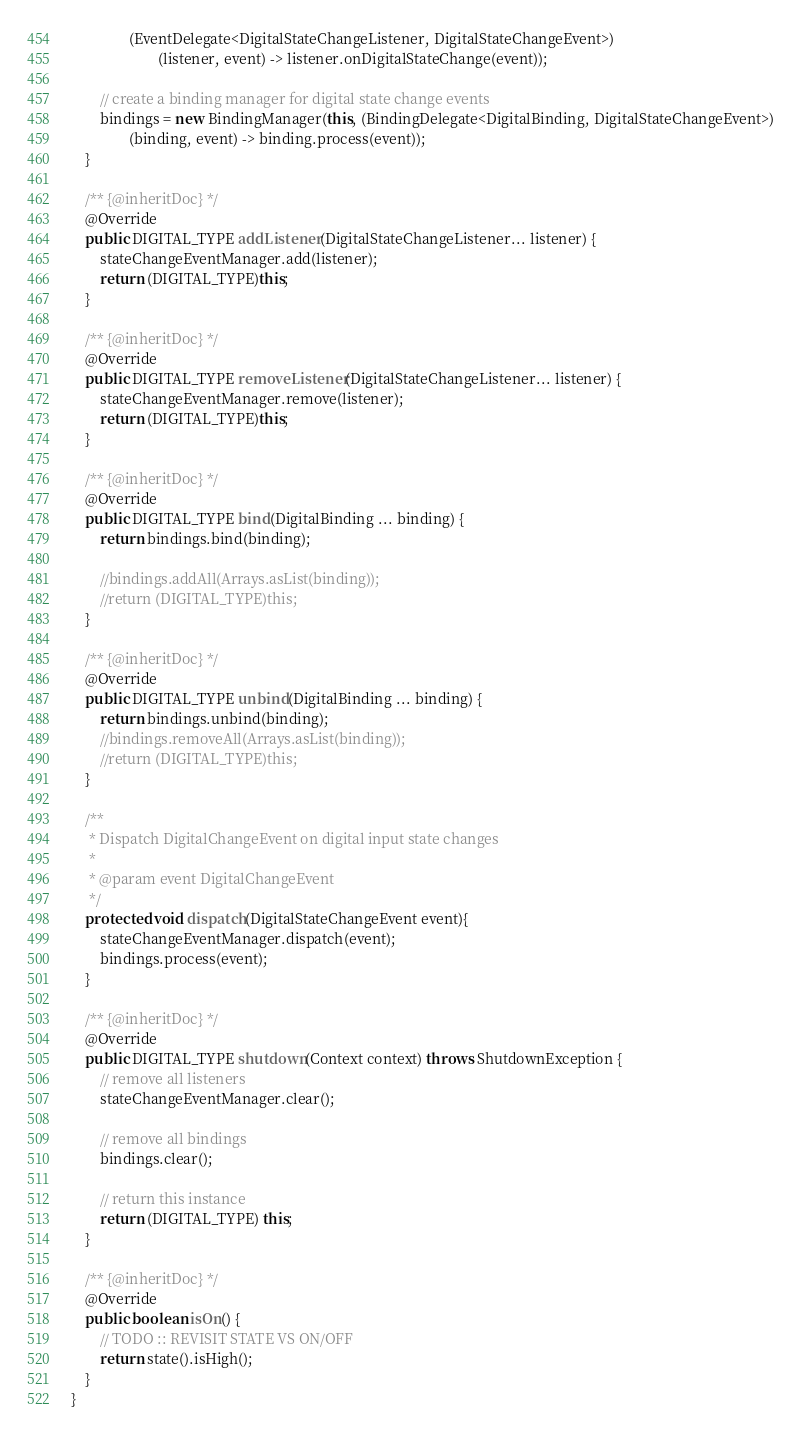<code> <loc_0><loc_0><loc_500><loc_500><_Java_>                (EventDelegate<DigitalStateChangeListener, DigitalStateChangeEvent>)
                        (listener, event) -> listener.onDigitalStateChange(event));

        // create a binding manager for digital state change events
        bindings = new BindingManager(this, (BindingDelegate<DigitalBinding, DigitalStateChangeEvent>)
                (binding, event) -> binding.process(event));
    }

    /** {@inheritDoc} */
    @Override
    public DIGITAL_TYPE addListener(DigitalStateChangeListener... listener) {
        stateChangeEventManager.add(listener);
        return (DIGITAL_TYPE)this;
    }

    /** {@inheritDoc} */
    @Override
    public DIGITAL_TYPE removeListener(DigitalStateChangeListener... listener) {
        stateChangeEventManager.remove(listener);
        return (DIGITAL_TYPE)this;
    }

    /** {@inheritDoc} */
    @Override
    public DIGITAL_TYPE bind(DigitalBinding ... binding) {
        return bindings.bind(binding);

        //bindings.addAll(Arrays.asList(binding));
        //return (DIGITAL_TYPE)this;
    }

    /** {@inheritDoc} */
    @Override
    public DIGITAL_TYPE unbind(DigitalBinding ... binding) {
        return bindings.unbind(binding);
        //bindings.removeAll(Arrays.asList(binding));
        //return (DIGITAL_TYPE)this;
    }

    /**
     * Dispatch DigitalChangeEvent on digital input state changes
     *
     * @param event DigitalChangeEvent
     */
    protected void dispatch(DigitalStateChangeEvent event){
        stateChangeEventManager.dispatch(event);
        bindings.process(event);
    }

    /** {@inheritDoc} */
    @Override
    public DIGITAL_TYPE shutdown(Context context) throws ShutdownException {
        // remove all listeners
        stateChangeEventManager.clear();

        // remove all bindings
        bindings.clear();

        // return this instance
        return (DIGITAL_TYPE) this;
    }

    /** {@inheritDoc} */
    @Override
    public boolean isOn() {
        // TODO :: REVISIT STATE VS ON/OFF
        return state().isHigh();
    }
}
</code> 